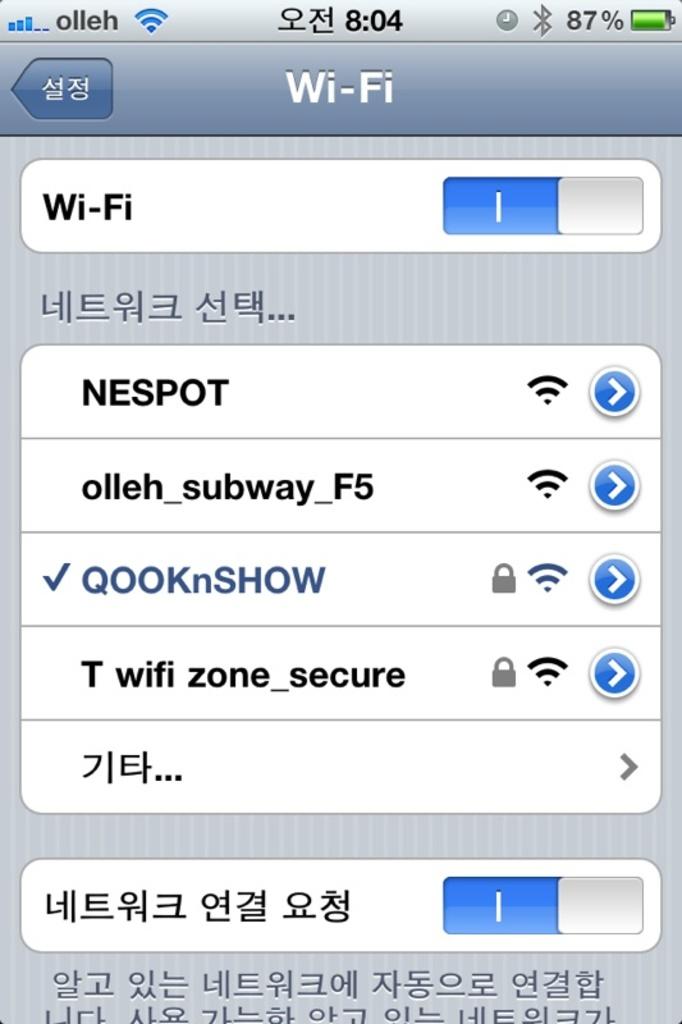What option menu is shown?
Provide a short and direct response. Wi-fi. 